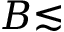<formula> <loc_0><loc_0><loc_500><loc_500>B { \lesssim }</formula> 